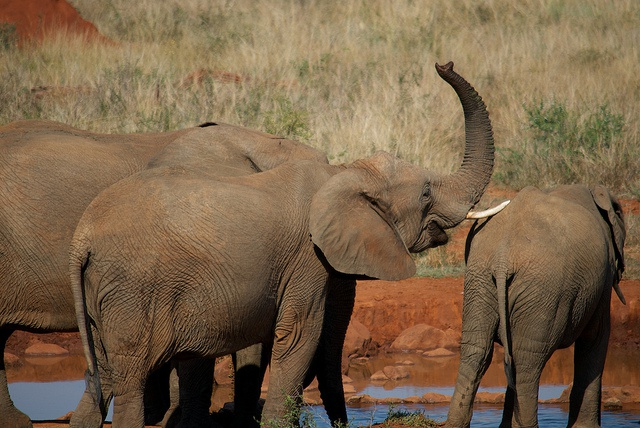Describe the objects in this image and their specific colors. I can see elephant in maroon, gray, and black tones, elephant in maroon, gray, and black tones, and elephant in maroon, black, and gray tones in this image. 